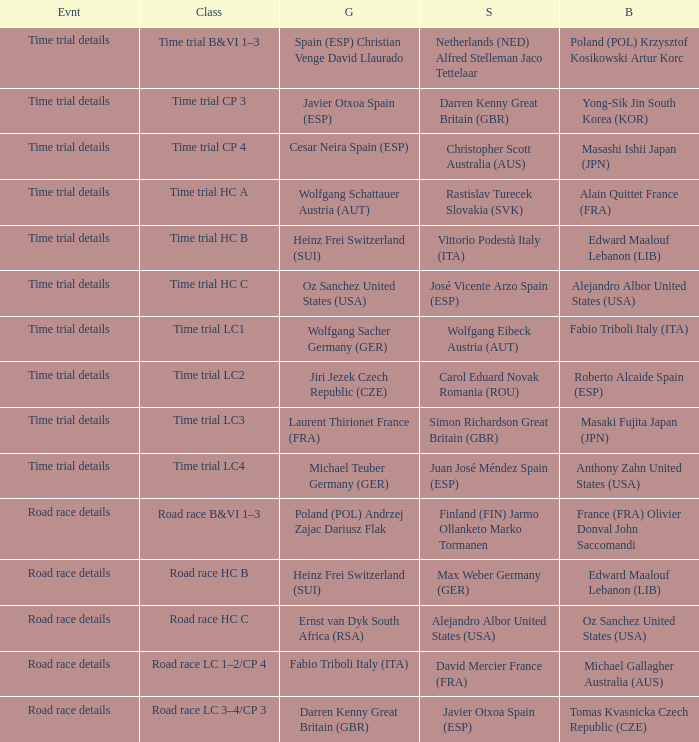What is the event when gold is darren kenny great britain (gbr)? Road race details. 